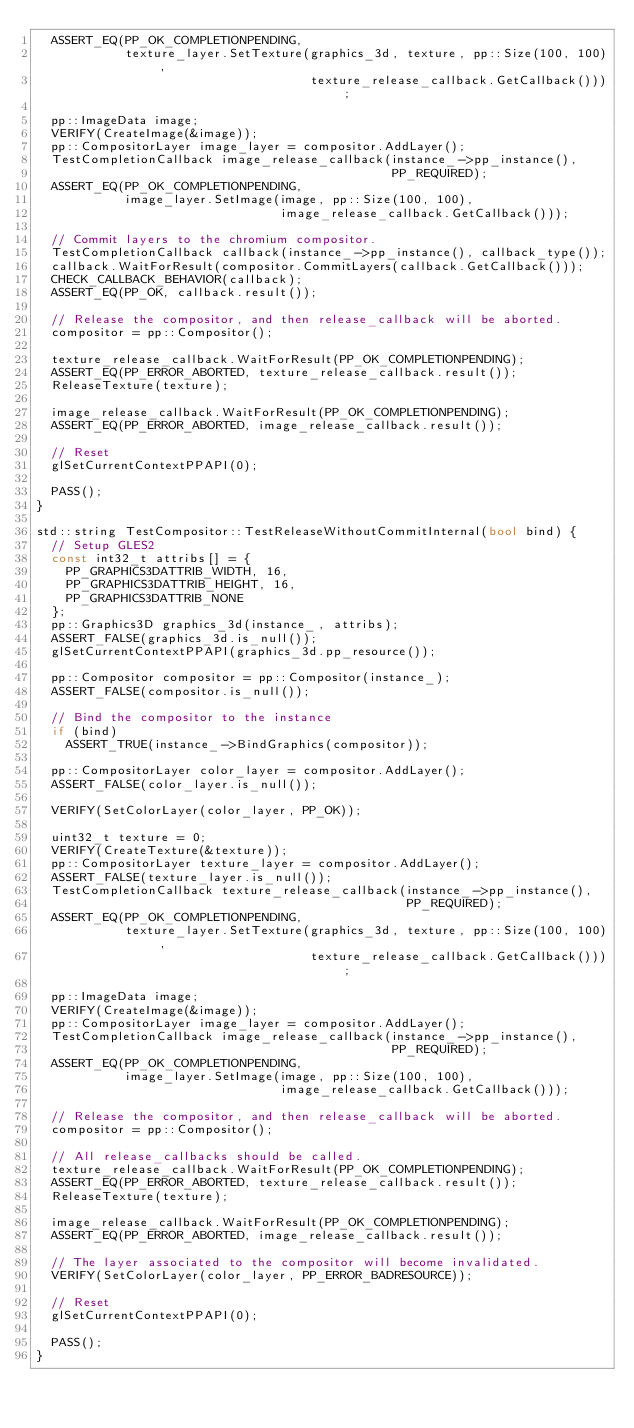Convert code to text. <code><loc_0><loc_0><loc_500><loc_500><_C++_>  ASSERT_EQ(PP_OK_COMPLETIONPENDING,
            texture_layer.SetTexture(graphics_3d, texture, pp::Size(100, 100),
                                     texture_release_callback.GetCallback()));

  pp::ImageData image;
  VERIFY(CreateImage(&image));
  pp::CompositorLayer image_layer = compositor.AddLayer();
  TestCompletionCallback image_release_callback(instance_->pp_instance(),
                                                PP_REQUIRED);
  ASSERT_EQ(PP_OK_COMPLETIONPENDING,
            image_layer.SetImage(image, pp::Size(100, 100),
                                 image_release_callback.GetCallback()));

  // Commit layers to the chromium compositor.
  TestCompletionCallback callback(instance_->pp_instance(), callback_type());
  callback.WaitForResult(compositor.CommitLayers(callback.GetCallback()));
  CHECK_CALLBACK_BEHAVIOR(callback);
  ASSERT_EQ(PP_OK, callback.result());

  // Release the compositor, and then release_callback will be aborted.
  compositor = pp::Compositor();

  texture_release_callback.WaitForResult(PP_OK_COMPLETIONPENDING);
  ASSERT_EQ(PP_ERROR_ABORTED, texture_release_callback.result());
  ReleaseTexture(texture);

  image_release_callback.WaitForResult(PP_OK_COMPLETIONPENDING);
  ASSERT_EQ(PP_ERROR_ABORTED, image_release_callback.result());

  // Reset
  glSetCurrentContextPPAPI(0);

  PASS();
}

std::string TestCompositor::TestReleaseWithoutCommitInternal(bool bind) {
  // Setup GLES2
  const int32_t attribs[] = {
    PP_GRAPHICS3DATTRIB_WIDTH, 16,
    PP_GRAPHICS3DATTRIB_HEIGHT, 16,
    PP_GRAPHICS3DATTRIB_NONE
  };
  pp::Graphics3D graphics_3d(instance_, attribs);
  ASSERT_FALSE(graphics_3d.is_null());
  glSetCurrentContextPPAPI(graphics_3d.pp_resource());

  pp::Compositor compositor = pp::Compositor(instance_);
  ASSERT_FALSE(compositor.is_null());

  // Bind the compositor to the instance
  if (bind)
    ASSERT_TRUE(instance_->BindGraphics(compositor));

  pp::CompositorLayer color_layer = compositor.AddLayer();
  ASSERT_FALSE(color_layer.is_null());

  VERIFY(SetColorLayer(color_layer, PP_OK));

  uint32_t texture = 0;
  VERIFY(CreateTexture(&texture));
  pp::CompositorLayer texture_layer = compositor.AddLayer();
  ASSERT_FALSE(texture_layer.is_null());
  TestCompletionCallback texture_release_callback(instance_->pp_instance(),
                                                  PP_REQUIRED);
  ASSERT_EQ(PP_OK_COMPLETIONPENDING,
            texture_layer.SetTexture(graphics_3d, texture, pp::Size(100, 100),
                                     texture_release_callback.GetCallback()));

  pp::ImageData image;
  VERIFY(CreateImage(&image));
  pp::CompositorLayer image_layer = compositor.AddLayer();
  TestCompletionCallback image_release_callback(instance_->pp_instance(),
                                                PP_REQUIRED);
  ASSERT_EQ(PP_OK_COMPLETIONPENDING,
            image_layer.SetImage(image, pp::Size(100, 100),
                                 image_release_callback.GetCallback()));

  // Release the compositor, and then release_callback will be aborted.
  compositor = pp::Compositor();

  // All release_callbacks should be called.
  texture_release_callback.WaitForResult(PP_OK_COMPLETIONPENDING);
  ASSERT_EQ(PP_ERROR_ABORTED, texture_release_callback.result());
  ReleaseTexture(texture);

  image_release_callback.WaitForResult(PP_OK_COMPLETIONPENDING);
  ASSERT_EQ(PP_ERROR_ABORTED, image_release_callback.result());

  // The layer associated to the compositor will become invalidated.
  VERIFY(SetColorLayer(color_layer, PP_ERROR_BADRESOURCE));

  // Reset
  glSetCurrentContextPPAPI(0);

  PASS();
}
</code> 